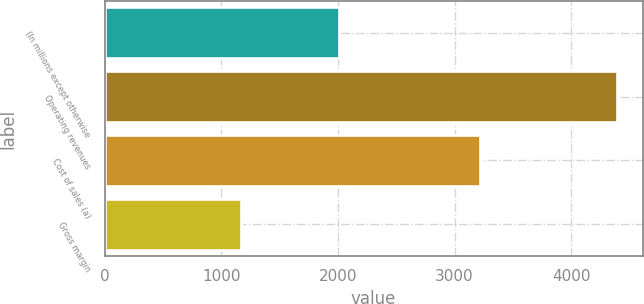Convert chart. <chart><loc_0><loc_0><loc_500><loc_500><bar_chart><fcel>(In millions except otherwise<fcel>Operating revenues<fcel>Cost of sales (a)<fcel>Gross margin<nl><fcel>2013<fcel>4392<fcel>3219<fcel>1173<nl></chart> 